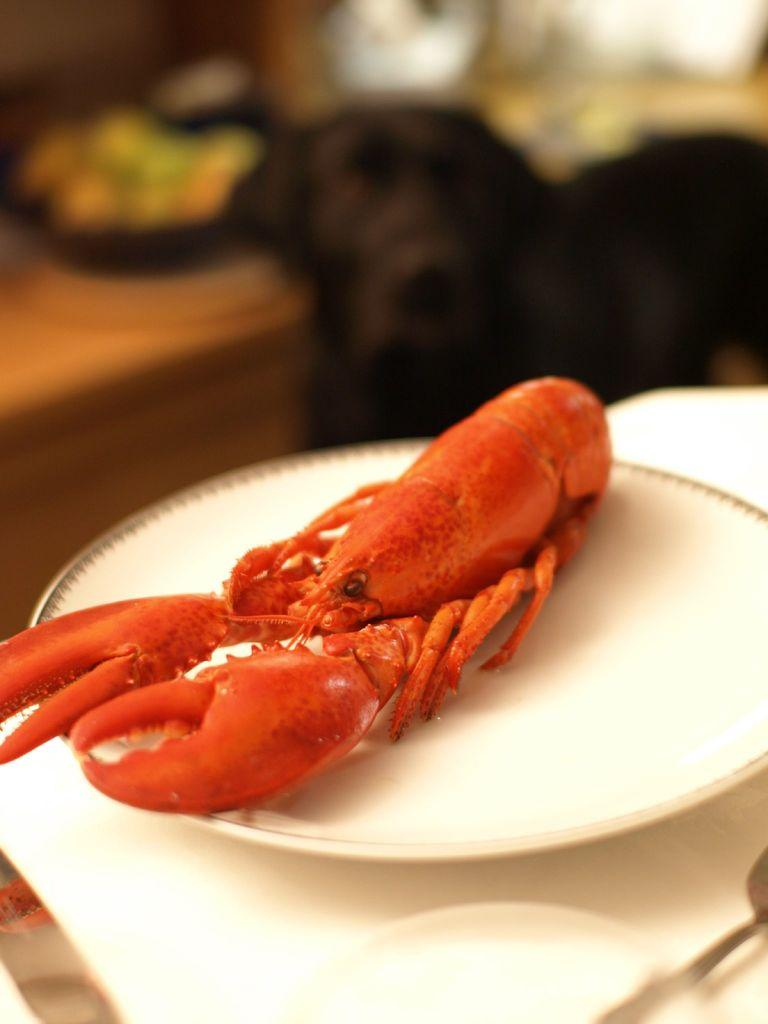What color is the crab in the image? The crab is red in color. What is the crab sitting on in the image? The crab is on a white color saucer. What color is the table in the image? The table is white in color. What utensil can be seen on the table? There is a spoon on the table. What other objects can be seen in the background of the image? There are other objects in the background, but their specific details are not mentioned in the provided facts. What level of writing can be seen on the crab's shell in the image? There is no writing visible on the crab's shell in the image. What rate of speed is the crab moving at in the image? The crab is not moving in the image; it is stationary on the saucer. 